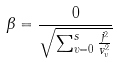<formula> <loc_0><loc_0><loc_500><loc_500>\beta = \frac { 0 } { \sqrt { \sum _ { \upsilon = 0 } ^ { s } \frac { j ^ { 2 } } { v _ { \upsilon } ^ { 2 } } } }</formula> 